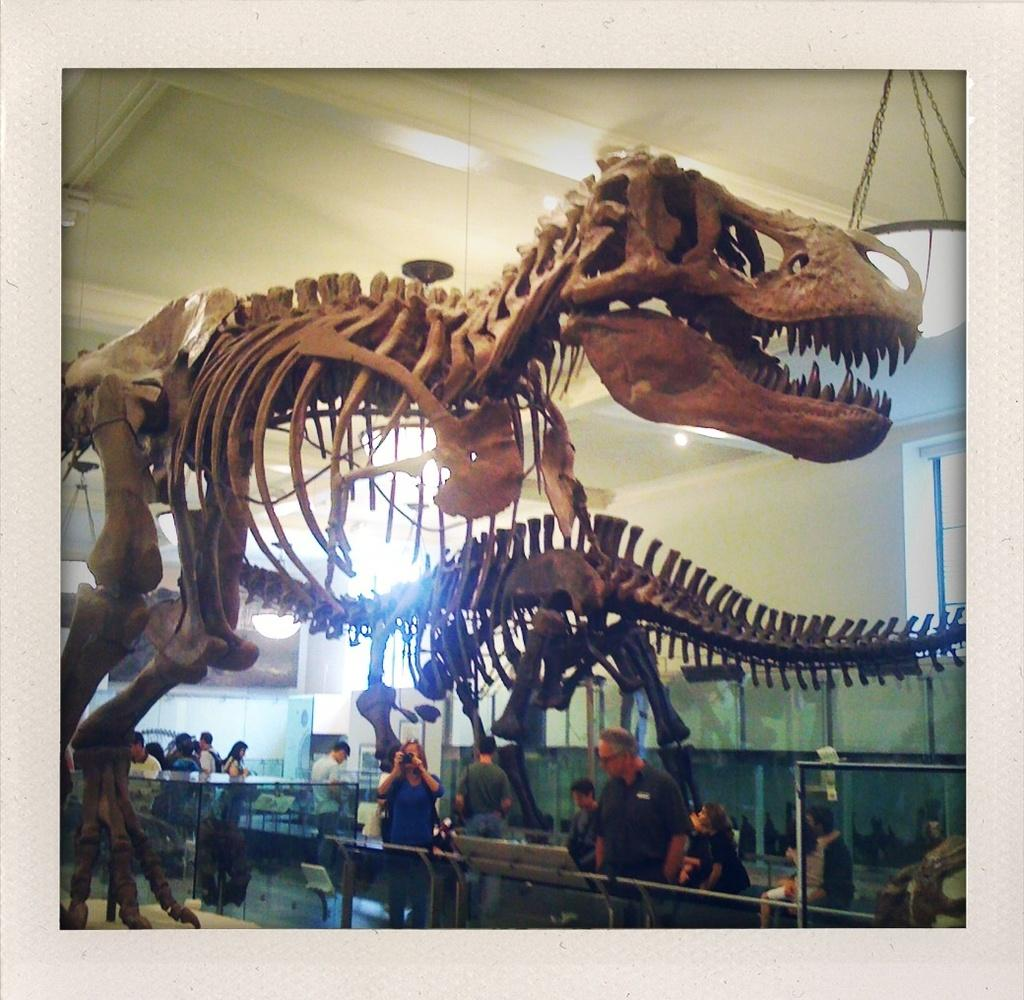What type of objects are featured in the image? There is a skeleton of a few animals in the image. Can you describe the people in the image? There are people visible from left to right in the image. What else can be seen in the image besides the skeletons and people? Some lights are visible at the top of the image. What type of breakfast is being prepared in the image? There is no breakfast preparation visible in the image. Can you tell me what type of camera is being used to take the picture? There is no camera visible in the image, as it is a still photograph. Are there any deer present in the image? There are no deer present in the image; it features a skeleton of a few animals. 